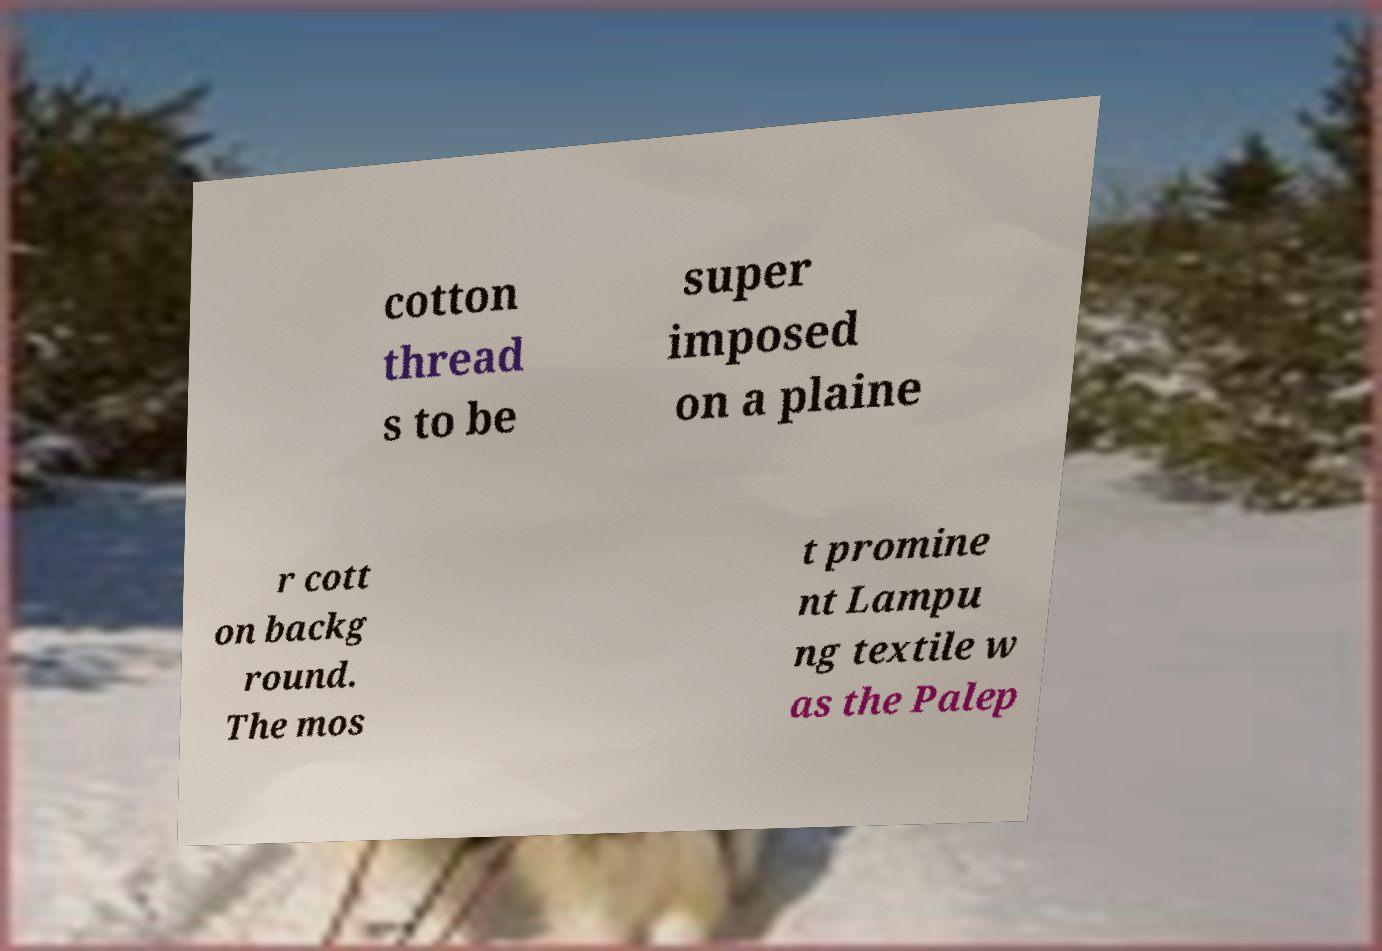Can you accurately transcribe the text from the provided image for me? cotton thread s to be super imposed on a plaine r cott on backg round. The mos t promine nt Lampu ng textile w as the Palep 